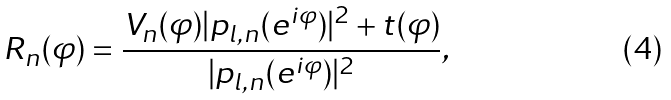<formula> <loc_0><loc_0><loc_500><loc_500>R _ { n } ( \varphi ) = \frac { V _ { n } ( \varphi ) | p _ { l , n } ( e ^ { i \varphi } ) | ^ { 2 } + t ( \varphi ) } { | p _ { l , n } ( e ^ { i \varphi } ) | ^ { 2 } } ,</formula> 